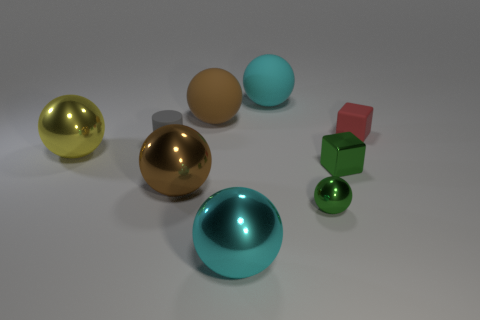How many things are large brown spheres in front of the tiny matte block or cylinders?
Make the answer very short. 2. What number of other things are the same material as the yellow object?
Provide a short and direct response. 4. What shape is the small metal thing that is the same color as the shiny cube?
Offer a terse response. Sphere. There is a cyan sphere behind the yellow sphere; how big is it?
Offer a very short reply. Large. There is a big brown thing that is the same material as the gray cylinder; what is its shape?
Keep it short and to the point. Sphere. Does the red thing have the same material as the large cyan object behind the small green sphere?
Your response must be concise. Yes. There is a small thing in front of the green metal block; is it the same shape as the tiny red matte object?
Provide a succinct answer. No. There is a yellow object that is the same shape as the brown matte object; what material is it?
Offer a terse response. Metal. There is a brown matte object; is its shape the same as the tiny thing that is in front of the green block?
Keep it short and to the point. Yes. There is a big metal object that is behind the tiny shiny sphere and right of the small gray matte thing; what color is it?
Provide a succinct answer. Brown. 